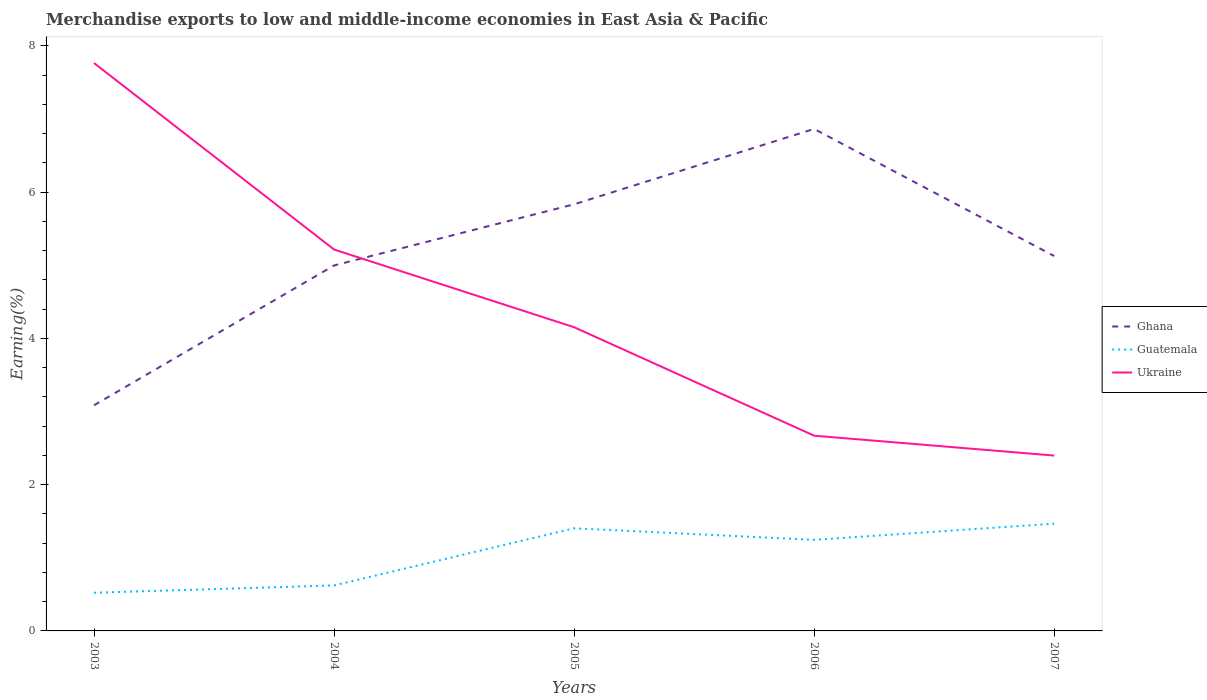Does the line corresponding to Ghana intersect with the line corresponding to Ukraine?
Keep it short and to the point. Yes. Across all years, what is the maximum percentage of amount earned from merchandise exports in Ghana?
Your answer should be compact. 3.09. What is the total percentage of amount earned from merchandise exports in Ghana in the graph?
Keep it short and to the point. -1.87. What is the difference between the highest and the second highest percentage of amount earned from merchandise exports in Ukraine?
Make the answer very short. 5.37. How are the legend labels stacked?
Provide a short and direct response. Vertical. What is the title of the graph?
Ensure brevity in your answer.  Merchandise exports to low and middle-income economies in East Asia & Pacific. What is the label or title of the X-axis?
Provide a succinct answer. Years. What is the label or title of the Y-axis?
Your answer should be very brief. Earning(%). What is the Earning(%) in Ghana in 2003?
Your answer should be very brief. 3.09. What is the Earning(%) in Guatemala in 2003?
Keep it short and to the point. 0.52. What is the Earning(%) in Ukraine in 2003?
Offer a terse response. 7.77. What is the Earning(%) in Ghana in 2004?
Offer a very short reply. 5. What is the Earning(%) in Guatemala in 2004?
Your response must be concise. 0.62. What is the Earning(%) of Ukraine in 2004?
Keep it short and to the point. 5.22. What is the Earning(%) of Ghana in 2005?
Ensure brevity in your answer.  5.83. What is the Earning(%) of Guatemala in 2005?
Ensure brevity in your answer.  1.4. What is the Earning(%) in Ukraine in 2005?
Your answer should be compact. 4.15. What is the Earning(%) of Ghana in 2006?
Your response must be concise. 6.87. What is the Earning(%) of Guatemala in 2006?
Provide a succinct answer. 1.25. What is the Earning(%) of Ukraine in 2006?
Your answer should be very brief. 2.67. What is the Earning(%) of Ghana in 2007?
Give a very brief answer. 5.13. What is the Earning(%) of Guatemala in 2007?
Ensure brevity in your answer.  1.47. What is the Earning(%) of Ukraine in 2007?
Ensure brevity in your answer.  2.4. Across all years, what is the maximum Earning(%) of Ghana?
Provide a short and direct response. 6.87. Across all years, what is the maximum Earning(%) of Guatemala?
Ensure brevity in your answer.  1.47. Across all years, what is the maximum Earning(%) in Ukraine?
Offer a very short reply. 7.77. Across all years, what is the minimum Earning(%) of Ghana?
Give a very brief answer. 3.09. Across all years, what is the minimum Earning(%) in Guatemala?
Offer a very short reply. 0.52. Across all years, what is the minimum Earning(%) in Ukraine?
Your answer should be compact. 2.4. What is the total Earning(%) of Ghana in the graph?
Your answer should be compact. 25.91. What is the total Earning(%) of Guatemala in the graph?
Make the answer very short. 5.26. What is the total Earning(%) in Ukraine in the graph?
Keep it short and to the point. 22.21. What is the difference between the Earning(%) in Ghana in 2003 and that in 2004?
Provide a succinct answer. -1.91. What is the difference between the Earning(%) in Guatemala in 2003 and that in 2004?
Your response must be concise. -0.1. What is the difference between the Earning(%) of Ukraine in 2003 and that in 2004?
Your response must be concise. 2.55. What is the difference between the Earning(%) in Ghana in 2003 and that in 2005?
Provide a succinct answer. -2.75. What is the difference between the Earning(%) of Guatemala in 2003 and that in 2005?
Provide a succinct answer. -0.88. What is the difference between the Earning(%) in Ukraine in 2003 and that in 2005?
Keep it short and to the point. 3.61. What is the difference between the Earning(%) of Ghana in 2003 and that in 2006?
Provide a succinct answer. -3.78. What is the difference between the Earning(%) of Guatemala in 2003 and that in 2006?
Make the answer very short. -0.72. What is the difference between the Earning(%) of Ukraine in 2003 and that in 2006?
Offer a terse response. 5.1. What is the difference between the Earning(%) in Ghana in 2003 and that in 2007?
Offer a terse response. -2.04. What is the difference between the Earning(%) in Guatemala in 2003 and that in 2007?
Offer a very short reply. -0.94. What is the difference between the Earning(%) in Ukraine in 2003 and that in 2007?
Make the answer very short. 5.37. What is the difference between the Earning(%) of Ghana in 2004 and that in 2005?
Offer a terse response. -0.84. What is the difference between the Earning(%) in Guatemala in 2004 and that in 2005?
Provide a short and direct response. -0.78. What is the difference between the Earning(%) of Ghana in 2004 and that in 2006?
Your response must be concise. -1.87. What is the difference between the Earning(%) in Guatemala in 2004 and that in 2006?
Provide a short and direct response. -0.62. What is the difference between the Earning(%) of Ukraine in 2004 and that in 2006?
Provide a succinct answer. 2.55. What is the difference between the Earning(%) of Ghana in 2004 and that in 2007?
Keep it short and to the point. -0.13. What is the difference between the Earning(%) of Guatemala in 2004 and that in 2007?
Ensure brevity in your answer.  -0.84. What is the difference between the Earning(%) in Ukraine in 2004 and that in 2007?
Ensure brevity in your answer.  2.82. What is the difference between the Earning(%) of Ghana in 2005 and that in 2006?
Your answer should be very brief. -1.03. What is the difference between the Earning(%) of Guatemala in 2005 and that in 2006?
Offer a very short reply. 0.16. What is the difference between the Earning(%) of Ukraine in 2005 and that in 2006?
Make the answer very short. 1.48. What is the difference between the Earning(%) of Ghana in 2005 and that in 2007?
Give a very brief answer. 0.71. What is the difference between the Earning(%) in Guatemala in 2005 and that in 2007?
Your response must be concise. -0.06. What is the difference between the Earning(%) in Ukraine in 2005 and that in 2007?
Provide a short and direct response. 1.76. What is the difference between the Earning(%) of Ghana in 2006 and that in 2007?
Offer a terse response. 1.74. What is the difference between the Earning(%) in Guatemala in 2006 and that in 2007?
Your answer should be very brief. -0.22. What is the difference between the Earning(%) in Ukraine in 2006 and that in 2007?
Keep it short and to the point. 0.27. What is the difference between the Earning(%) in Ghana in 2003 and the Earning(%) in Guatemala in 2004?
Your answer should be compact. 2.46. What is the difference between the Earning(%) in Ghana in 2003 and the Earning(%) in Ukraine in 2004?
Your answer should be compact. -2.13. What is the difference between the Earning(%) in Guatemala in 2003 and the Earning(%) in Ukraine in 2004?
Provide a succinct answer. -4.69. What is the difference between the Earning(%) in Ghana in 2003 and the Earning(%) in Guatemala in 2005?
Ensure brevity in your answer.  1.68. What is the difference between the Earning(%) of Ghana in 2003 and the Earning(%) of Ukraine in 2005?
Make the answer very short. -1.07. What is the difference between the Earning(%) of Guatemala in 2003 and the Earning(%) of Ukraine in 2005?
Keep it short and to the point. -3.63. What is the difference between the Earning(%) in Ghana in 2003 and the Earning(%) in Guatemala in 2006?
Your answer should be compact. 1.84. What is the difference between the Earning(%) of Ghana in 2003 and the Earning(%) of Ukraine in 2006?
Make the answer very short. 0.42. What is the difference between the Earning(%) of Guatemala in 2003 and the Earning(%) of Ukraine in 2006?
Ensure brevity in your answer.  -2.15. What is the difference between the Earning(%) in Ghana in 2003 and the Earning(%) in Guatemala in 2007?
Provide a succinct answer. 1.62. What is the difference between the Earning(%) of Ghana in 2003 and the Earning(%) of Ukraine in 2007?
Provide a short and direct response. 0.69. What is the difference between the Earning(%) of Guatemala in 2003 and the Earning(%) of Ukraine in 2007?
Provide a succinct answer. -1.88. What is the difference between the Earning(%) in Ghana in 2004 and the Earning(%) in Guatemala in 2005?
Provide a succinct answer. 3.59. What is the difference between the Earning(%) of Ghana in 2004 and the Earning(%) of Ukraine in 2005?
Give a very brief answer. 0.84. What is the difference between the Earning(%) in Guatemala in 2004 and the Earning(%) in Ukraine in 2005?
Keep it short and to the point. -3.53. What is the difference between the Earning(%) of Ghana in 2004 and the Earning(%) of Guatemala in 2006?
Give a very brief answer. 3.75. What is the difference between the Earning(%) of Ghana in 2004 and the Earning(%) of Ukraine in 2006?
Ensure brevity in your answer.  2.33. What is the difference between the Earning(%) of Guatemala in 2004 and the Earning(%) of Ukraine in 2006?
Offer a very short reply. -2.05. What is the difference between the Earning(%) of Ghana in 2004 and the Earning(%) of Guatemala in 2007?
Ensure brevity in your answer.  3.53. What is the difference between the Earning(%) in Ghana in 2004 and the Earning(%) in Ukraine in 2007?
Offer a terse response. 2.6. What is the difference between the Earning(%) in Guatemala in 2004 and the Earning(%) in Ukraine in 2007?
Your answer should be very brief. -1.78. What is the difference between the Earning(%) of Ghana in 2005 and the Earning(%) of Guatemala in 2006?
Offer a very short reply. 4.59. What is the difference between the Earning(%) of Ghana in 2005 and the Earning(%) of Ukraine in 2006?
Offer a terse response. 3.16. What is the difference between the Earning(%) of Guatemala in 2005 and the Earning(%) of Ukraine in 2006?
Make the answer very short. -1.27. What is the difference between the Earning(%) in Ghana in 2005 and the Earning(%) in Guatemala in 2007?
Offer a very short reply. 4.37. What is the difference between the Earning(%) of Ghana in 2005 and the Earning(%) of Ukraine in 2007?
Make the answer very short. 3.44. What is the difference between the Earning(%) of Guatemala in 2005 and the Earning(%) of Ukraine in 2007?
Give a very brief answer. -0.99. What is the difference between the Earning(%) of Ghana in 2006 and the Earning(%) of Guatemala in 2007?
Your answer should be compact. 5.4. What is the difference between the Earning(%) of Ghana in 2006 and the Earning(%) of Ukraine in 2007?
Provide a succinct answer. 4.47. What is the difference between the Earning(%) of Guatemala in 2006 and the Earning(%) of Ukraine in 2007?
Ensure brevity in your answer.  -1.15. What is the average Earning(%) of Ghana per year?
Provide a short and direct response. 5.18. What is the average Earning(%) of Guatemala per year?
Offer a terse response. 1.05. What is the average Earning(%) of Ukraine per year?
Give a very brief answer. 4.44. In the year 2003, what is the difference between the Earning(%) of Ghana and Earning(%) of Guatemala?
Keep it short and to the point. 2.56. In the year 2003, what is the difference between the Earning(%) in Ghana and Earning(%) in Ukraine?
Offer a very short reply. -4.68. In the year 2003, what is the difference between the Earning(%) of Guatemala and Earning(%) of Ukraine?
Keep it short and to the point. -7.24. In the year 2004, what is the difference between the Earning(%) of Ghana and Earning(%) of Guatemala?
Provide a short and direct response. 4.38. In the year 2004, what is the difference between the Earning(%) in Ghana and Earning(%) in Ukraine?
Keep it short and to the point. -0.22. In the year 2004, what is the difference between the Earning(%) of Guatemala and Earning(%) of Ukraine?
Offer a terse response. -4.59. In the year 2005, what is the difference between the Earning(%) of Ghana and Earning(%) of Guatemala?
Your response must be concise. 4.43. In the year 2005, what is the difference between the Earning(%) in Ghana and Earning(%) in Ukraine?
Ensure brevity in your answer.  1.68. In the year 2005, what is the difference between the Earning(%) in Guatemala and Earning(%) in Ukraine?
Your response must be concise. -2.75. In the year 2006, what is the difference between the Earning(%) of Ghana and Earning(%) of Guatemala?
Keep it short and to the point. 5.62. In the year 2006, what is the difference between the Earning(%) of Ghana and Earning(%) of Ukraine?
Your answer should be compact. 4.2. In the year 2006, what is the difference between the Earning(%) of Guatemala and Earning(%) of Ukraine?
Make the answer very short. -1.42. In the year 2007, what is the difference between the Earning(%) in Ghana and Earning(%) in Guatemala?
Your response must be concise. 3.66. In the year 2007, what is the difference between the Earning(%) in Ghana and Earning(%) in Ukraine?
Your answer should be compact. 2.73. In the year 2007, what is the difference between the Earning(%) in Guatemala and Earning(%) in Ukraine?
Give a very brief answer. -0.93. What is the ratio of the Earning(%) of Ghana in 2003 to that in 2004?
Provide a short and direct response. 0.62. What is the ratio of the Earning(%) of Guatemala in 2003 to that in 2004?
Offer a terse response. 0.84. What is the ratio of the Earning(%) in Ukraine in 2003 to that in 2004?
Your answer should be very brief. 1.49. What is the ratio of the Earning(%) of Ghana in 2003 to that in 2005?
Give a very brief answer. 0.53. What is the ratio of the Earning(%) of Guatemala in 2003 to that in 2005?
Offer a very short reply. 0.37. What is the ratio of the Earning(%) in Ukraine in 2003 to that in 2005?
Your response must be concise. 1.87. What is the ratio of the Earning(%) of Ghana in 2003 to that in 2006?
Your answer should be very brief. 0.45. What is the ratio of the Earning(%) in Guatemala in 2003 to that in 2006?
Offer a terse response. 0.42. What is the ratio of the Earning(%) in Ukraine in 2003 to that in 2006?
Offer a very short reply. 2.91. What is the ratio of the Earning(%) in Ghana in 2003 to that in 2007?
Provide a short and direct response. 0.6. What is the ratio of the Earning(%) of Guatemala in 2003 to that in 2007?
Your answer should be very brief. 0.36. What is the ratio of the Earning(%) of Ukraine in 2003 to that in 2007?
Provide a short and direct response. 3.24. What is the ratio of the Earning(%) of Ghana in 2004 to that in 2005?
Your answer should be very brief. 0.86. What is the ratio of the Earning(%) of Guatemala in 2004 to that in 2005?
Offer a terse response. 0.44. What is the ratio of the Earning(%) of Ukraine in 2004 to that in 2005?
Keep it short and to the point. 1.26. What is the ratio of the Earning(%) of Ghana in 2004 to that in 2006?
Provide a short and direct response. 0.73. What is the ratio of the Earning(%) in Guatemala in 2004 to that in 2006?
Your answer should be compact. 0.5. What is the ratio of the Earning(%) in Ukraine in 2004 to that in 2006?
Provide a succinct answer. 1.95. What is the ratio of the Earning(%) in Ghana in 2004 to that in 2007?
Provide a succinct answer. 0.97. What is the ratio of the Earning(%) of Guatemala in 2004 to that in 2007?
Your response must be concise. 0.42. What is the ratio of the Earning(%) in Ukraine in 2004 to that in 2007?
Keep it short and to the point. 2.18. What is the ratio of the Earning(%) of Ghana in 2005 to that in 2006?
Offer a terse response. 0.85. What is the ratio of the Earning(%) in Guatemala in 2005 to that in 2006?
Ensure brevity in your answer.  1.13. What is the ratio of the Earning(%) of Ukraine in 2005 to that in 2006?
Your answer should be very brief. 1.56. What is the ratio of the Earning(%) in Ghana in 2005 to that in 2007?
Ensure brevity in your answer.  1.14. What is the ratio of the Earning(%) of Guatemala in 2005 to that in 2007?
Your answer should be compact. 0.96. What is the ratio of the Earning(%) in Ukraine in 2005 to that in 2007?
Offer a very short reply. 1.73. What is the ratio of the Earning(%) in Ghana in 2006 to that in 2007?
Provide a short and direct response. 1.34. What is the ratio of the Earning(%) in Guatemala in 2006 to that in 2007?
Provide a short and direct response. 0.85. What is the ratio of the Earning(%) of Ukraine in 2006 to that in 2007?
Provide a short and direct response. 1.11. What is the difference between the highest and the second highest Earning(%) of Ghana?
Your response must be concise. 1.03. What is the difference between the highest and the second highest Earning(%) of Guatemala?
Provide a short and direct response. 0.06. What is the difference between the highest and the second highest Earning(%) in Ukraine?
Provide a succinct answer. 2.55. What is the difference between the highest and the lowest Earning(%) in Ghana?
Offer a terse response. 3.78. What is the difference between the highest and the lowest Earning(%) of Guatemala?
Keep it short and to the point. 0.94. What is the difference between the highest and the lowest Earning(%) in Ukraine?
Your answer should be very brief. 5.37. 